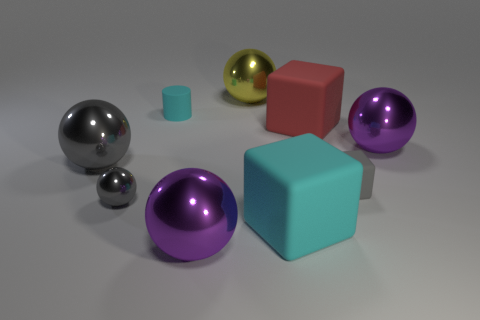There is a purple object in front of the large purple object that is to the right of the metallic object that is behind the red block; what is its size? The size of the purple object in front of the larger purple object, to the right of the metallic one which is behind the red block, can be described as medium in comparison to other objects in the image. 